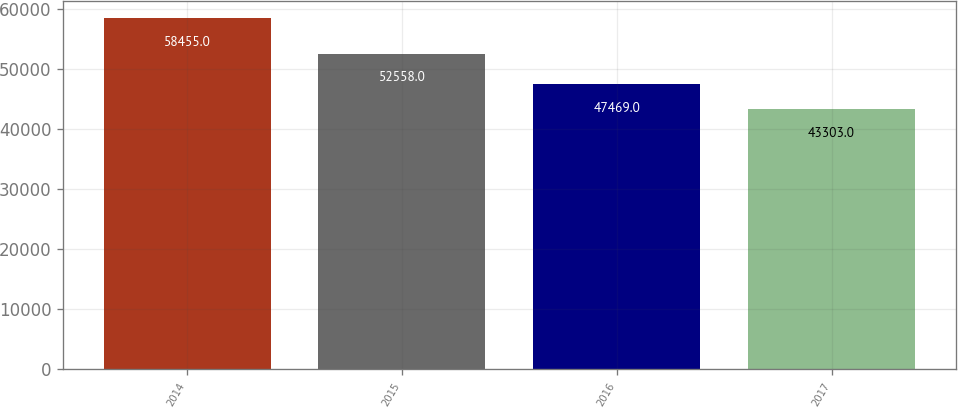<chart> <loc_0><loc_0><loc_500><loc_500><bar_chart><fcel>2014<fcel>2015<fcel>2016<fcel>2017<nl><fcel>58455<fcel>52558<fcel>47469<fcel>43303<nl></chart> 